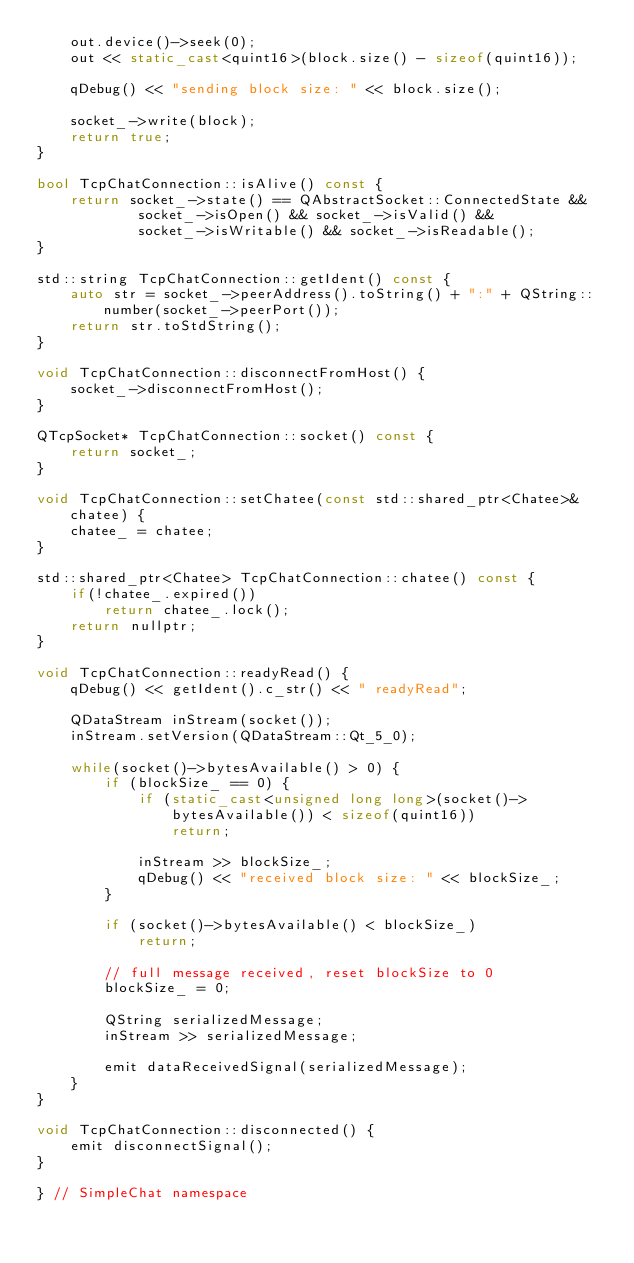<code> <loc_0><loc_0><loc_500><loc_500><_C++_>    out.device()->seek(0);
    out << static_cast<quint16>(block.size() - sizeof(quint16));

    qDebug() << "sending block size: " << block.size();

    socket_->write(block);
    return true;
}

bool TcpChatConnection::isAlive() const {
    return socket_->state() == QAbstractSocket::ConnectedState &&
            socket_->isOpen() && socket_->isValid() &&
            socket_->isWritable() && socket_->isReadable();
}

std::string TcpChatConnection::getIdent() const {
    auto str = socket_->peerAddress().toString() + ":" + QString::number(socket_->peerPort());
    return str.toStdString();
}

void TcpChatConnection::disconnectFromHost() {
    socket_->disconnectFromHost();
}

QTcpSocket* TcpChatConnection::socket() const {
    return socket_;
}

void TcpChatConnection::setChatee(const std::shared_ptr<Chatee>& chatee) {
    chatee_ = chatee;
}

std::shared_ptr<Chatee> TcpChatConnection::chatee() const {
    if(!chatee_.expired())
        return chatee_.lock();
    return nullptr;
}

void TcpChatConnection::readyRead() {
    qDebug() << getIdent().c_str() << " readyRead";

    QDataStream inStream(socket());
    inStream.setVersion(QDataStream::Qt_5_0);

    while(socket()->bytesAvailable() > 0) {
        if (blockSize_ == 0) {
            if (static_cast<unsigned long long>(socket()->bytesAvailable()) < sizeof(quint16))
                return;

            inStream >> blockSize_;
            qDebug() << "received block size: " << blockSize_;
        }

        if (socket()->bytesAvailable() < blockSize_)
            return;

        // full message received, reset blockSize to 0
        blockSize_ = 0;

        QString serializedMessage;
        inStream >> serializedMessage;

        emit dataReceivedSignal(serializedMessage);
    }
}

void TcpChatConnection::disconnected() {
    emit disconnectSignal();
}

} // SimpleChat namespace
</code> 